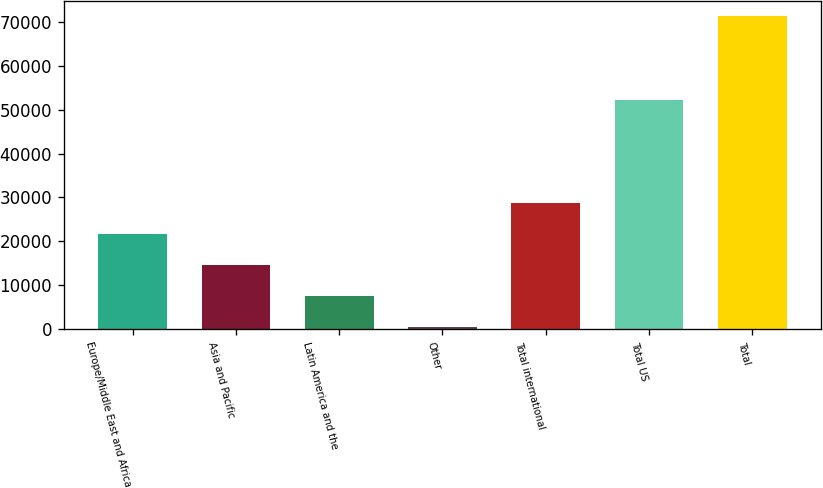Convert chart. <chart><loc_0><loc_0><loc_500><loc_500><bar_chart><fcel>Europe/Middle East and Africa<fcel>Asia and Pacific<fcel>Latin America and the<fcel>Other<fcel>Total international<fcel>Total US<fcel>Total<nl><fcel>21696.5<fcel>14600<fcel>7503.5<fcel>407<fcel>28793<fcel>52137<fcel>71372<nl></chart> 